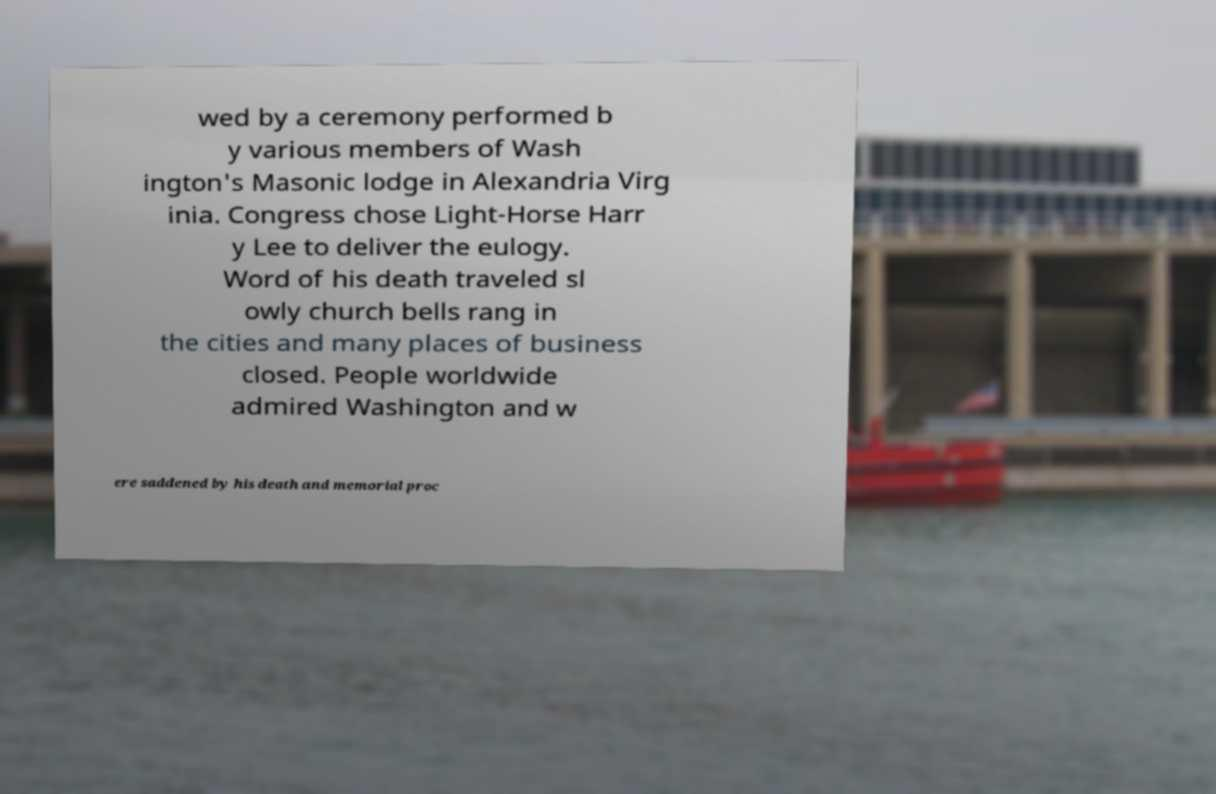Could you extract and type out the text from this image? wed by a ceremony performed b y various members of Wash ington's Masonic lodge in Alexandria Virg inia. Congress chose Light-Horse Harr y Lee to deliver the eulogy. Word of his death traveled sl owly church bells rang in the cities and many places of business closed. People worldwide admired Washington and w ere saddened by his death and memorial proc 